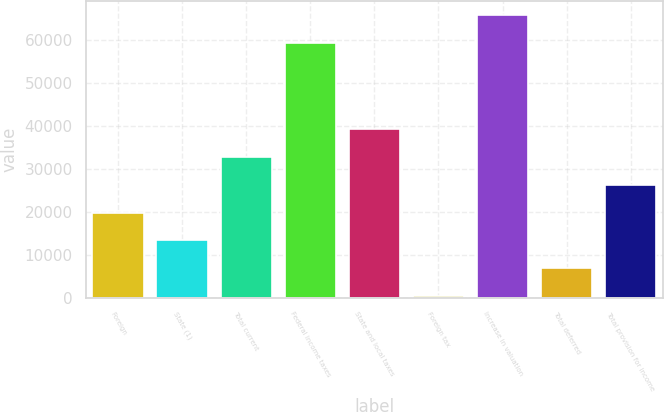<chart> <loc_0><loc_0><loc_500><loc_500><bar_chart><fcel>Foreign<fcel>State (1)<fcel>Total current<fcel>Federal income taxes<fcel>State and local taxes<fcel>Foreign tax<fcel>Increase in valuation<fcel>Total deferred<fcel>Total provision for income<nl><fcel>19800.7<fcel>13329.8<fcel>32742.5<fcel>59363<fcel>39213.4<fcel>388<fcel>65833.9<fcel>6858.9<fcel>26271.6<nl></chart> 